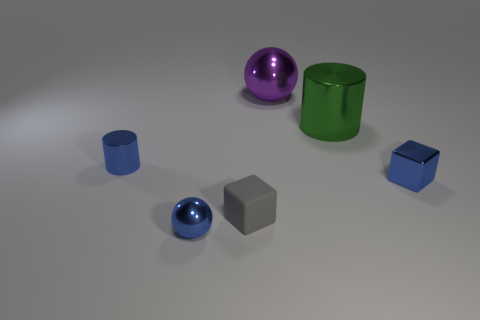Subtract all gray blocks. How many blocks are left? 1 Subtract all cylinders. How many objects are left? 4 Subtract 2 cylinders. How many cylinders are left? 0 Add 4 large purple metal cylinders. How many objects exist? 10 Subtract 1 blue balls. How many objects are left? 5 Subtract all yellow blocks. Subtract all yellow cylinders. How many blocks are left? 2 Subtract all green balls. How many blue blocks are left? 1 Subtract all gray matte cubes. Subtract all large purple objects. How many objects are left? 4 Add 4 tiny rubber cubes. How many tiny rubber cubes are left? 5 Add 5 small gray shiny cubes. How many small gray shiny cubes exist? 5 